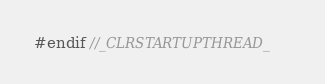Convert code to text. <code><loc_0><loc_0><loc_500><loc_500><_C_>
#endif //_CLRSTARTUPTHREAD_
</code> 